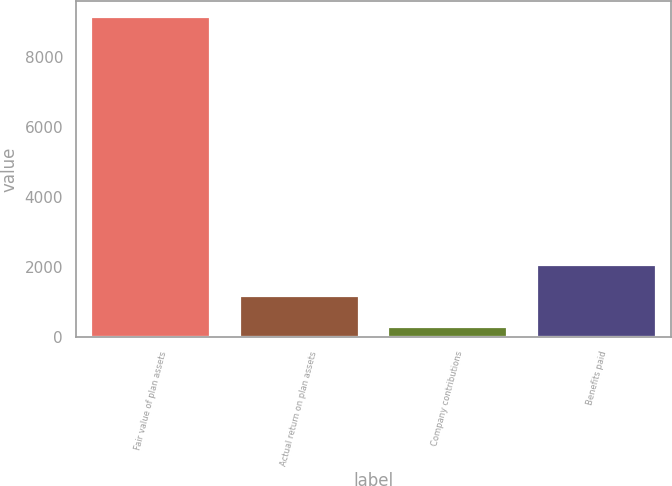<chart> <loc_0><loc_0><loc_500><loc_500><bar_chart><fcel>Fair value of plan assets<fcel>Actual return on plan assets<fcel>Company contributions<fcel>Benefits paid<nl><fcel>9142<fcel>1174.3<fcel>289<fcel>2059.6<nl></chart> 